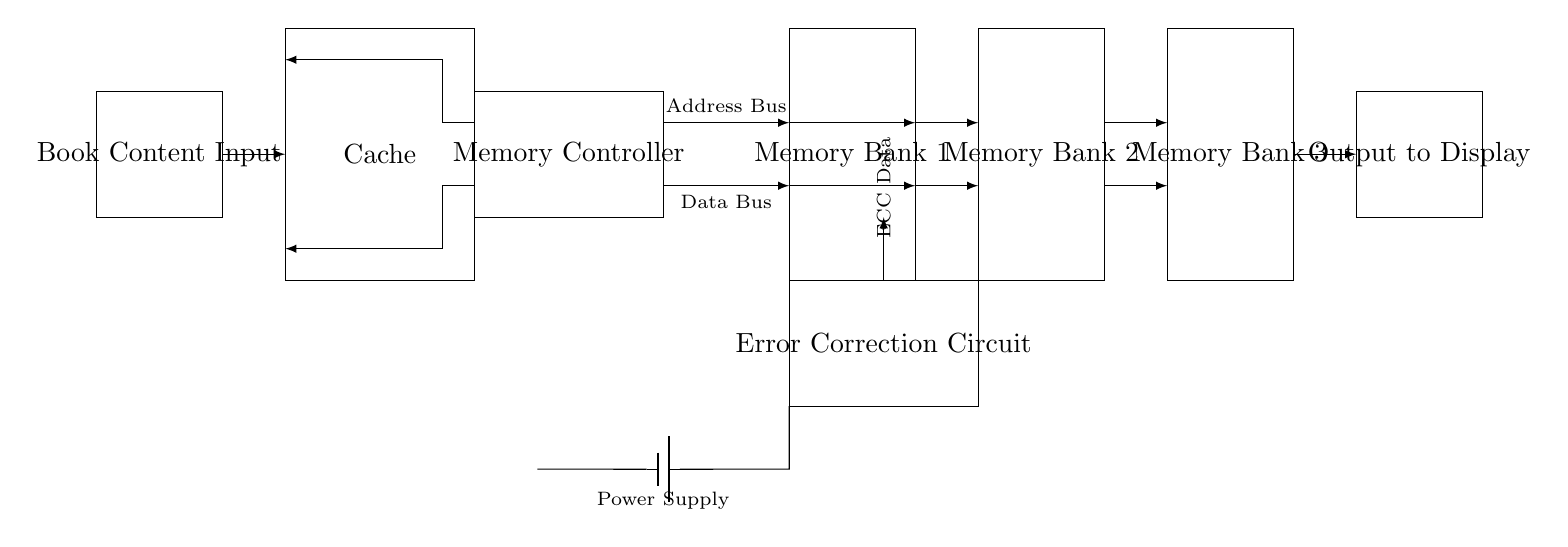What is the function of the Memory Controller? The Memory Controller manages data flow between the memory banks and other components like the caches and error correction circuits, coordinating address and data buses.
Answer: Memory management What connects the Memory Controller to the Memory Banks? The Memory Controller is connected to the Memory Banks via the Address Bus and Data Bus indicated by arrows showing the direction of data flow.
Answer: Address and Data Buses How many Memory Banks are in the circuit? There are three Memory Banks shown in the circuit, each represented by rectangles labeled Memory Bank 1, Memory Bank 2, and Memory Bank 3.
Answer: Three What type of additional circuitry is used in this design for data integrity? An Error Correction Circuit is included in the design to manage and correct errors in the data stored and retrieved from memory.
Answer: Error Correction Circuit Where does the Book Content Input component connect in the circuit? The Book Content Input connects to the Cache, which then connects to the Memory Controller to enable data transfer and storage operations in the circuit.
Answer: To the Cache What is the purpose of the Cache in this design? The Cache in this design acts as a temporary storage area for frequently accessed data to speed up the retrieval process before it is stored or retrieved from the Memory Banks.
Answer: Fast data retrieval What is the main output destination for the circuit? The circuit outputs to a component labeled Output to Display, indicating that the processed book content can be viewed after passing through the necessary memory and correction processes.
Answer: Output to Display 